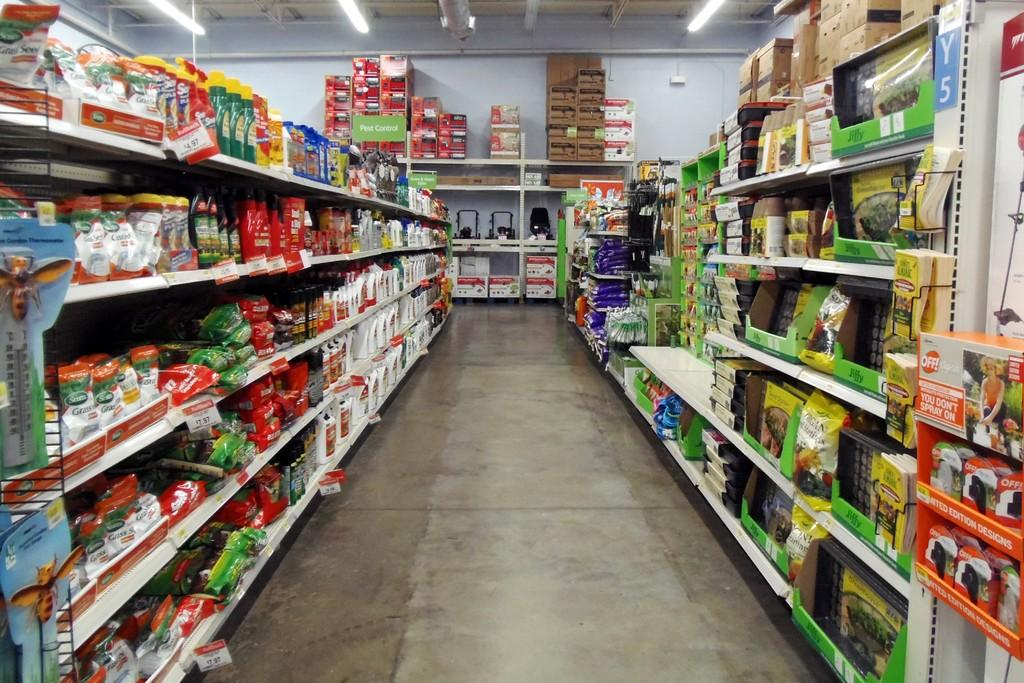<image>
Give a short and clear explanation of the subsequent image. a store and an aisle located on Y5 